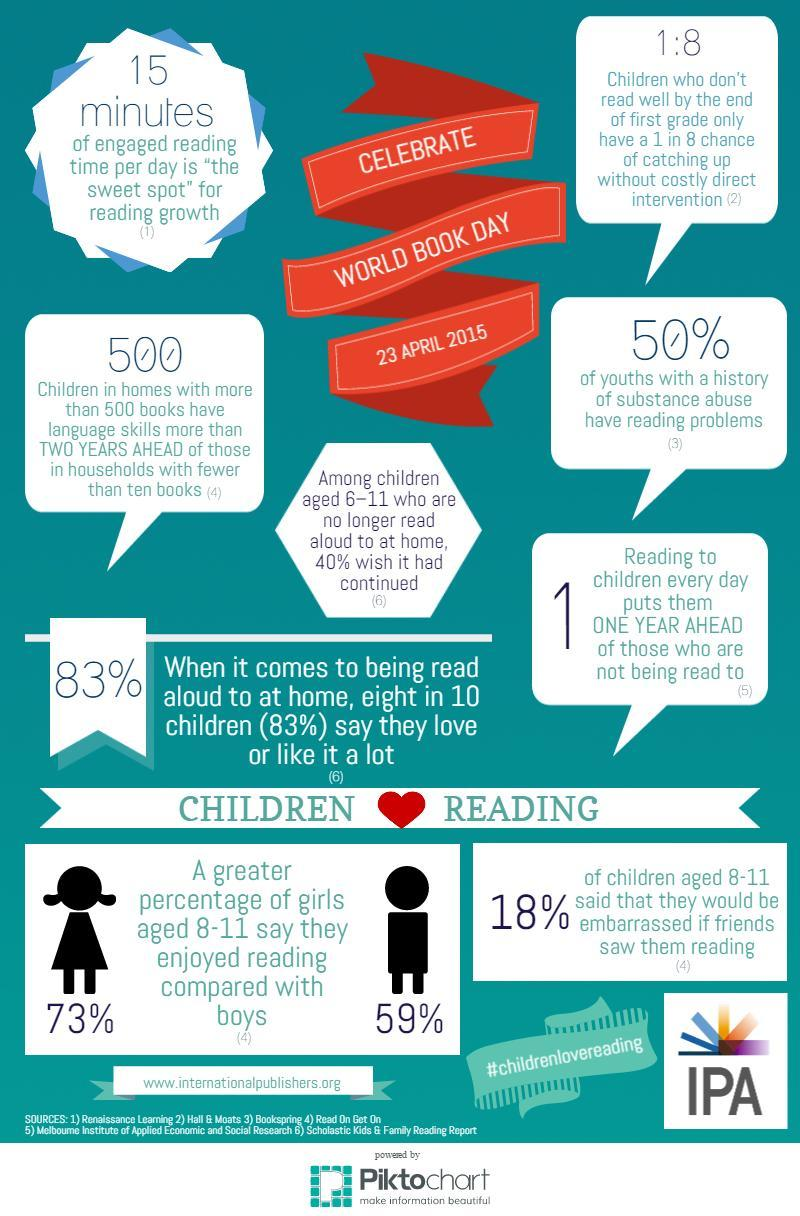What percent of girls aged 8-11 enjoyed reading?
Answer the question with a short phrase. 73% What percent of boys aged 8-11 enjoyed reading? 59% How many of youths with addiction issues have difficulty in reading? 50% 